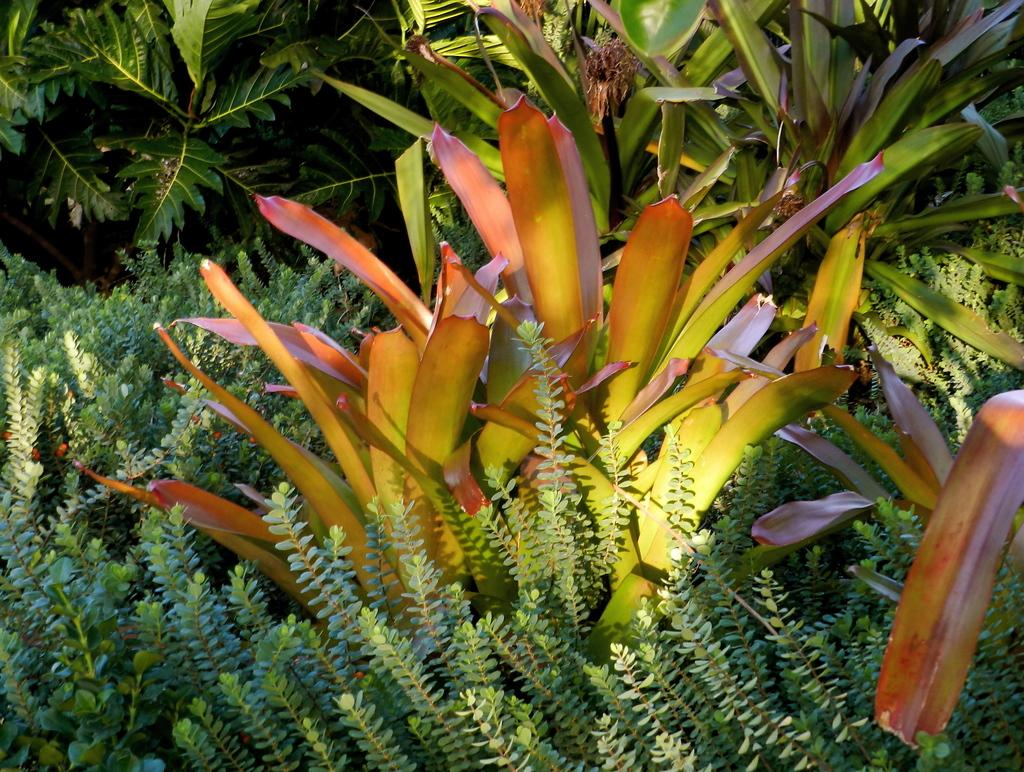What types of plants can be seen in the image? There are different types of plants in the image. What colors are the plants in the image? Some plants are green, yellow, and orange in color. What type of pain is the plant experiencing in the image? There is no indication of pain in the image; the plants are simply different colors. 